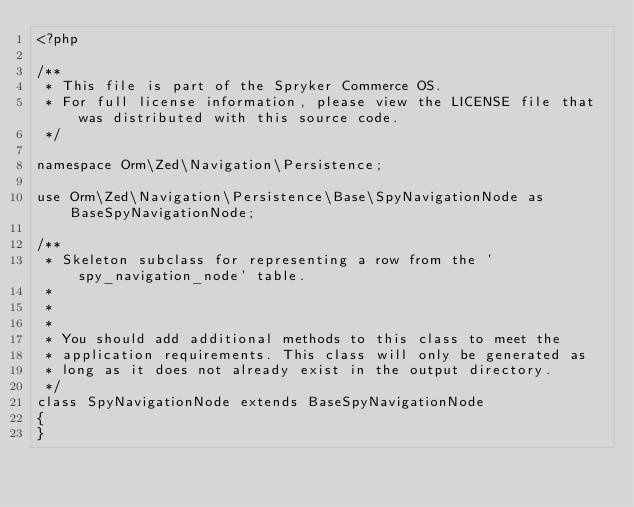<code> <loc_0><loc_0><loc_500><loc_500><_PHP_><?php

/**
 * This file is part of the Spryker Commerce OS.
 * For full license information, please view the LICENSE file that was distributed with this source code.
 */

namespace Orm\Zed\Navigation\Persistence;

use Orm\Zed\Navigation\Persistence\Base\SpyNavigationNode as BaseSpyNavigationNode;

/**
 * Skeleton subclass for representing a row from the 'spy_navigation_node' table.
 *
 *
 *
 * You should add additional methods to this class to meet the
 * application requirements. This class will only be generated as
 * long as it does not already exist in the output directory.
 */
class SpyNavigationNode extends BaseSpyNavigationNode
{
}
</code> 